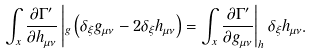<formula> <loc_0><loc_0><loc_500><loc_500>\int _ { x } \frac { \partial \Gamma ^ { \prime } } { \partial h _ { \mu \nu } } \left | _ { g } \left ( \delta _ { \xi } g _ { \mu \nu } - 2 \delta _ { \xi } h _ { \mu \nu } \right ) = \int _ { x } \frac { \partial \Gamma ^ { \prime } } { \partial g _ { \mu \nu } } \right | _ { h } \delta _ { \xi } h _ { \mu \nu } .</formula> 